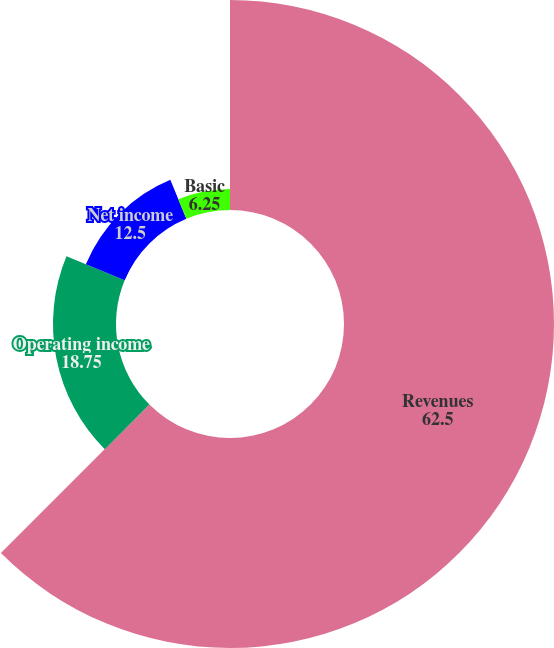<chart> <loc_0><loc_0><loc_500><loc_500><pie_chart><fcel>Revenues<fcel>Operating income<fcel>Net income<fcel>Basic<fcel>Diluted<nl><fcel>62.5%<fcel>18.75%<fcel>12.5%<fcel>6.25%<fcel>0.0%<nl></chart> 